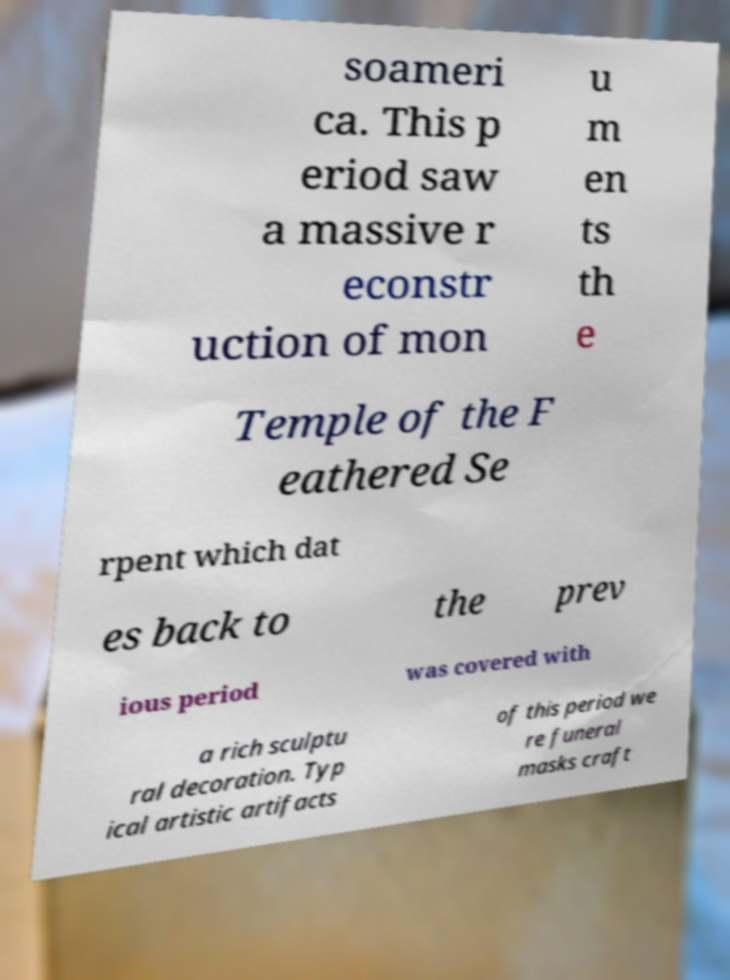Please read and relay the text visible in this image. What does it say? soameri ca. This p eriod saw a massive r econstr uction of mon u m en ts th e Temple of the F eathered Se rpent which dat es back to the prev ious period was covered with a rich sculptu ral decoration. Typ ical artistic artifacts of this period we re funeral masks craft 